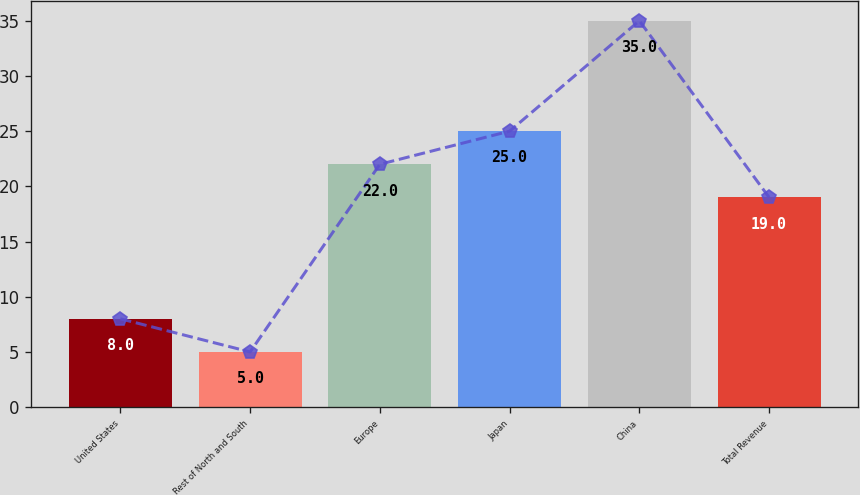<chart> <loc_0><loc_0><loc_500><loc_500><bar_chart><fcel>United States<fcel>Rest of North and South<fcel>Europe<fcel>Japan<fcel>China<fcel>Total Revenue<nl><fcel>8<fcel>5<fcel>22<fcel>25<fcel>35<fcel>19<nl></chart> 